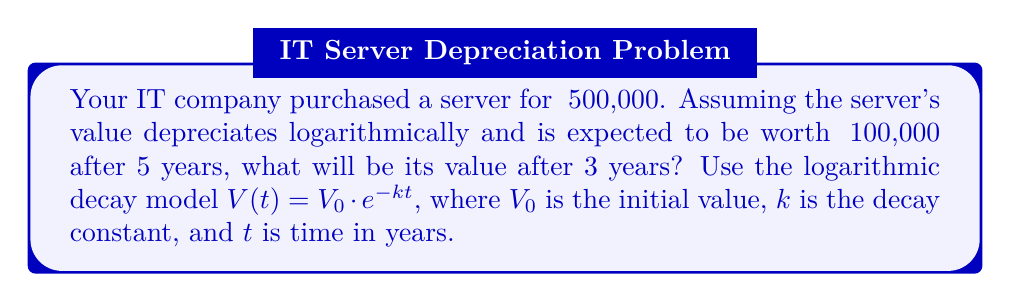Solve this math problem. To solve this problem, we'll follow these steps:

1. Determine the decay constant $k$ using the given information.
2. Use the calculated $k$ to find the value after 3 years.

Step 1: Determine the decay constant $k$

We know that:
$V_0 = 500,000$ (initial value)
$V(5) = 100,000$ (value after 5 years)

Using the logarithmic decay model:
$$100,000 = 500,000 \cdot e^{-5k}$$

Dividing both sides by 500,000:
$$\frac{1}{5} = e^{-5k}$$

Taking the natural logarithm of both sides:
$$\ln(\frac{1}{5}) = -5k$$

Solving for $k$:
$$k = -\frac{\ln(\frac{1}{5})}{5} = \frac{\ln(5)}{5} \approx 0.3219$$

Step 2: Calculate the value after 3 years

Now that we have $k$, we can use the logarithmic decay model to find the value after 3 years:

$$V(3) = 500,000 \cdot e^{-0.3219 \cdot 3}$$

$$V(3) = 500,000 \cdot e^{-0.9657}$$

$$V(3) = 500,000 \cdot 0.3808$$

$$V(3) = 190,400$$

Therefore, the value of the server after 3 years will be approximately ₹190,400.
Answer: ₹190,400 